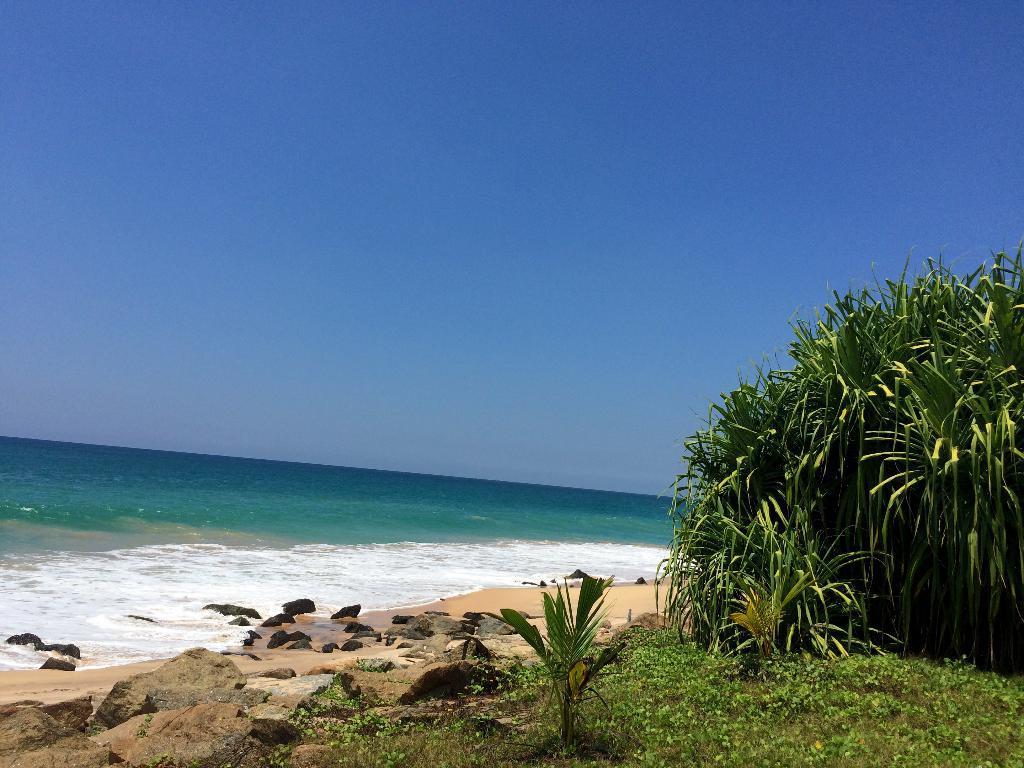Please provide a concise description of this image. In this image we can see sky, ocean, stones, rocks, sand, plants, bushes. 